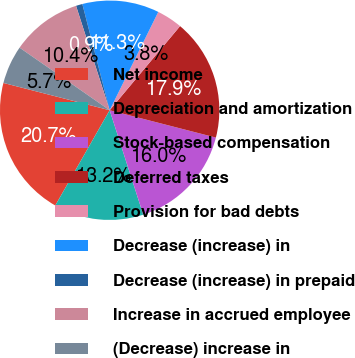Convert chart. <chart><loc_0><loc_0><loc_500><loc_500><pie_chart><fcel>Net income<fcel>Depreciation and amortization<fcel>Stock-based compensation<fcel>Deferred taxes<fcel>Provision for bad debts<fcel>Decrease (increase) in<fcel>Decrease (increase) in prepaid<fcel>Increase in accrued employee<fcel>(Decrease) increase in<nl><fcel>20.75%<fcel>13.21%<fcel>16.04%<fcel>17.92%<fcel>3.78%<fcel>11.32%<fcel>0.95%<fcel>10.38%<fcel>5.66%<nl></chart> 